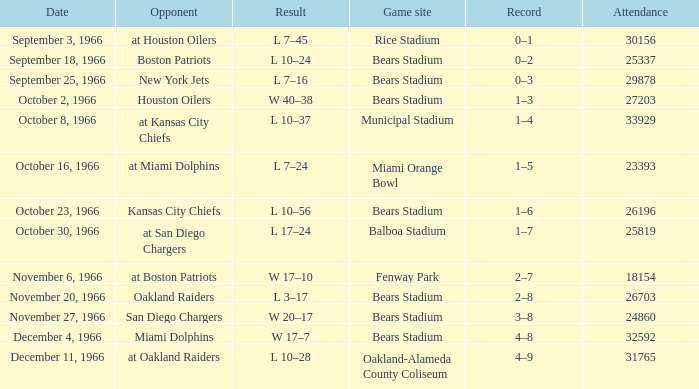Could you parse the entire table? {'header': ['Date', 'Opponent', 'Result', 'Game site', 'Record', 'Attendance'], 'rows': [['September 3, 1966', 'at Houston Oilers', 'L 7–45', 'Rice Stadium', '0–1', '30156'], ['September 18, 1966', 'Boston Patriots', 'L 10–24', 'Bears Stadium', '0–2', '25337'], ['September 25, 1966', 'New York Jets', 'L 7–16', 'Bears Stadium', '0–3', '29878'], ['October 2, 1966', 'Houston Oilers', 'W 40–38', 'Bears Stadium', '1–3', '27203'], ['October 8, 1966', 'at Kansas City Chiefs', 'L 10–37', 'Municipal Stadium', '1–4', '33929'], ['October 16, 1966', 'at Miami Dolphins', 'L 7–24', 'Miami Orange Bowl', '1–5', '23393'], ['October 23, 1966', 'Kansas City Chiefs', 'L 10–56', 'Bears Stadium', '1–6', '26196'], ['October 30, 1966', 'at San Diego Chargers', 'L 17–24', 'Balboa Stadium', '1–7', '25819'], ['November 6, 1966', 'at Boston Patriots', 'W 17–10', 'Fenway Park', '2–7', '18154'], ['November 20, 1966', 'Oakland Raiders', 'L 3–17', 'Bears Stadium', '2–8', '26703'], ['November 27, 1966', 'San Diego Chargers', 'W 20–17', 'Bears Stadium', '3–8', '24860'], ['December 4, 1966', 'Miami Dolphins', 'W 17–7', 'Bears Stadium', '4–8', '32592'], ['December 11, 1966', 'at Oakland Raiders', 'L 10–28', 'Oakland-Alameda County Coliseum', '4–9', '31765']]} How many findings are shown for week 13? 1.0. 